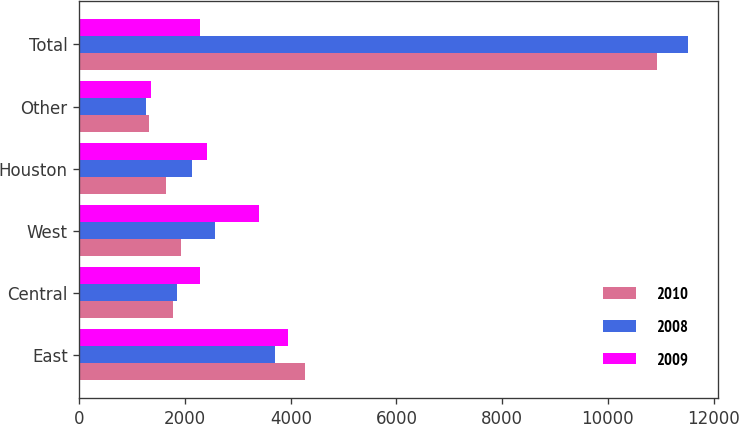<chart> <loc_0><loc_0><loc_500><loc_500><stacked_bar_chart><ecel><fcel>East<fcel>Central<fcel>West<fcel>Houston<fcel>Other<fcel>Total<nl><fcel>2010<fcel>4270<fcel>1769<fcel>1922<fcel>1641<fcel>1326<fcel>10928<nl><fcel>2008<fcel>3710<fcel>1840<fcel>2569<fcel>2130<fcel>1261<fcel>11510<nl><fcel>2009<fcel>3953<fcel>2280<fcel>3396<fcel>2416<fcel>1346<fcel>2280<nl></chart> 